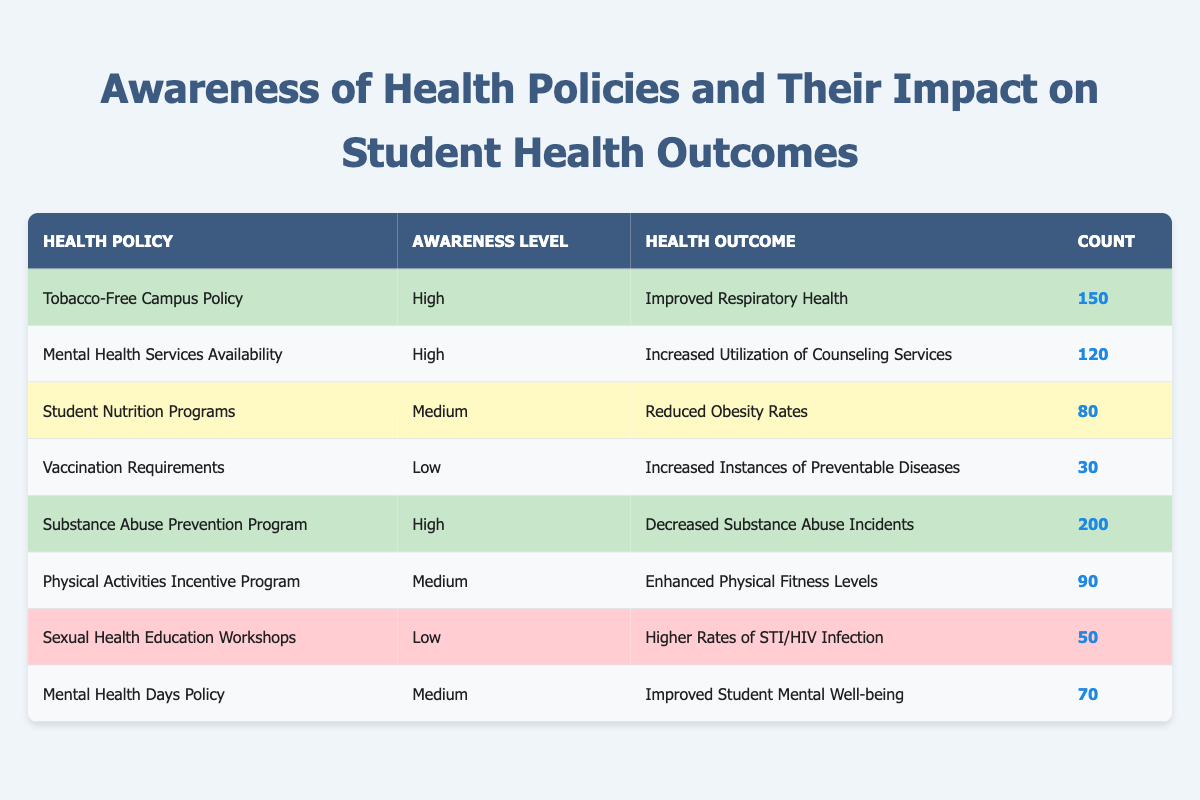What is the count of students aware of the Tobacco-Free Campus Policy? The table lists the Tobacco-Free Campus Policy with a count of 150 under the High awareness level.
Answer: 150 Which health outcome has the highest count associated with a health policy? The highest count in the table is for the Substance Abuse Prevention Program, which has a count of 200 for the health outcome "Decreased Substance Abuse Incidents."
Answer: 200 Are there more health outcomes with Low awareness level compared to High awareness level? The table shows 3 health outcomes with Low awareness (Vaccination Requirements, Sexual Health Education Workshops) and 3 health outcomes with High awareness (Tobacco-Free Campus Policy, Mental Health Services Availability, Substance Abuse Prevention Program), so they are equal.
Answer: No What is the total count of students aware of Medium level health policies? The count of students for Medium level awareness includes 80 (Student Nutrition Programs) + 90 (Physical Activities Incentive Program) + 70 (Mental Health Days Policy) = 240.
Answer: 240 Is it true that all health outcomes with High awareness levels show positive health impacts? The health outcomes listed under High awareness levels are "Improved Respiratory Health," "Increased Utilization of Counseling Services," and "Decreased Substance Abuse Incidents," all of which are positive impacts; thus, the statement is true.
Answer: Yes What is the average count of students for all health policies listed? The counts from all health policies are 150, 120, 80, 30, 200, 90, 50, and 70. The total sum is 150 + 120 + 80 + 30 + 200 + 90 + 50 + 70 = 890. There are 8 policies, so the average is 890 / 8 = 111.25.
Answer: 111.25 How many health policies have a count of less than 100? The health policies with a count of less than 100 are Vaccination Requirements (30), Student Nutrition Programs (80), Sexual Health Education Workshops (50), and Mental Health Days Policy (70). That's 4 policies in total.
Answer: 4 Which awareness level has the lowest average count? The counts for Low awareness level are 30 (Vaccination Requirements) and 50 (Sexual Health Education Workshops). The average for Low awareness is (30 + 50) / 2 = 40. Medium awareness counts are (80 + 90 + 70) / 3 = 80. High awareness counts are (150 + 120 + 200) / 3 = 156.67. The lowest average is for Low awareness.
Answer: Low 